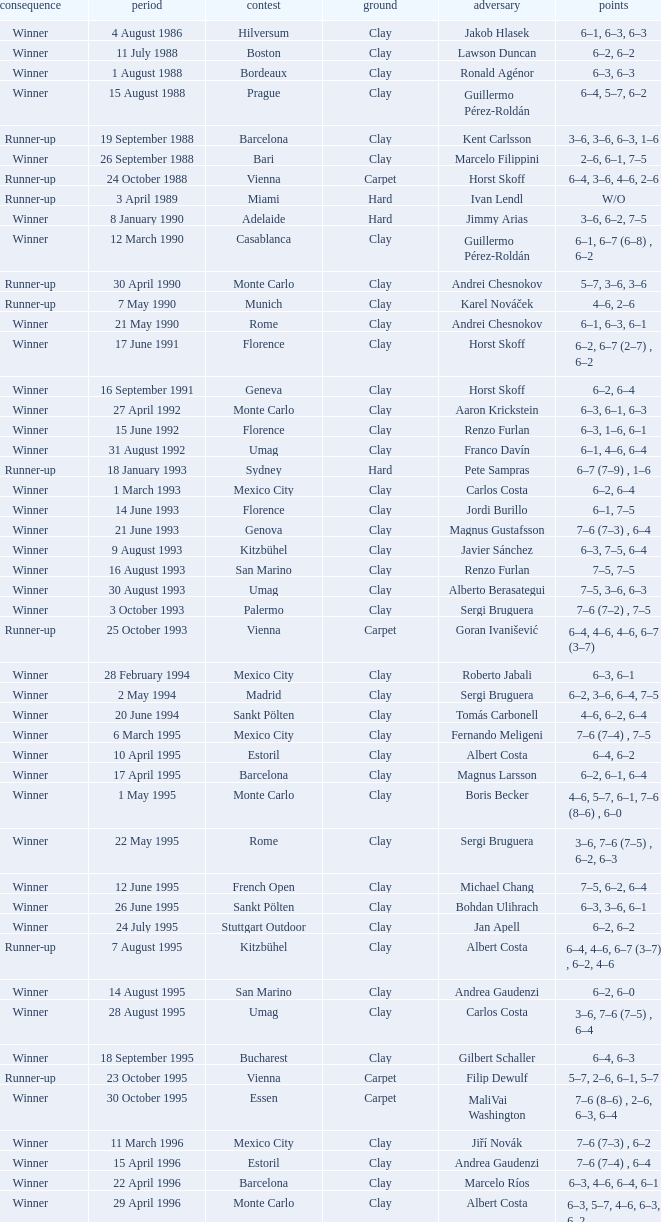Who is the opponent when the surface is clay, the outcome is winner and the championship is estoril on 15 april 1996? Andrea Gaudenzi. 